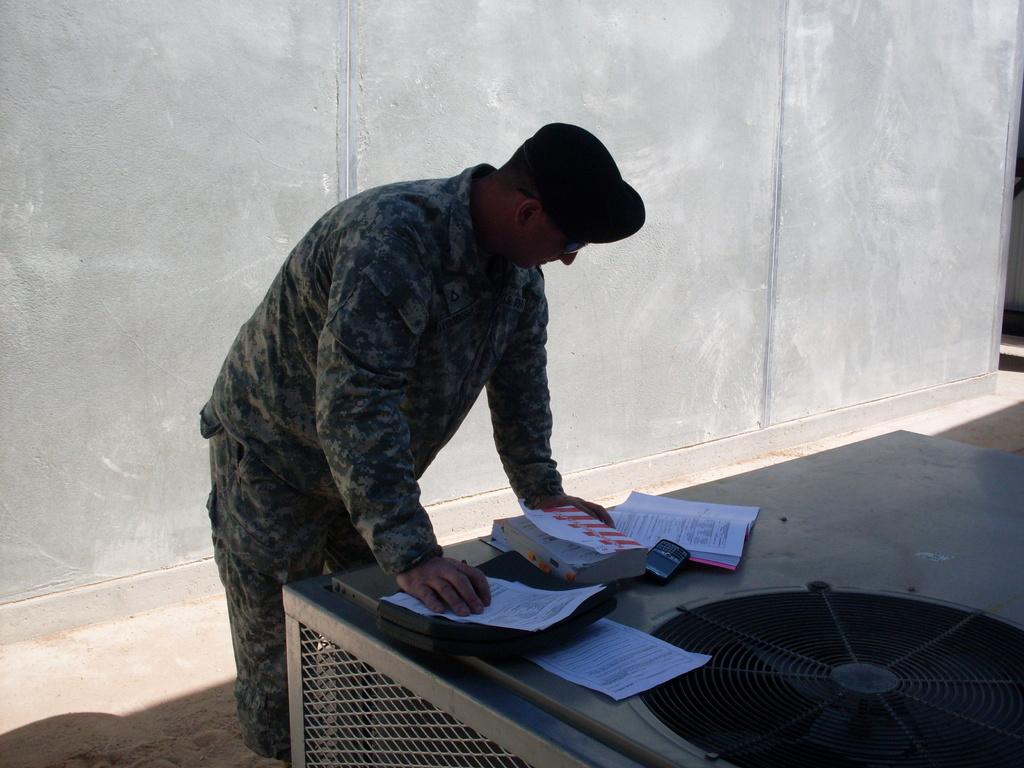Who is present in the image? There is a man in the image. What is the man wearing? The man is wearing a camouflage dress and cap. What is the man doing in the image? The man is leaning on a table. What items can be seen on the table? There are books, papers, and a fan on the table. What is visible in the background of the image? There is a wall visible in the background. What is the cause of the war depicted in the image? There is no war depicted in the image; it features a man leaning on a table with various items. How many women are present in the image? There are no women present in the image; it features a man. 